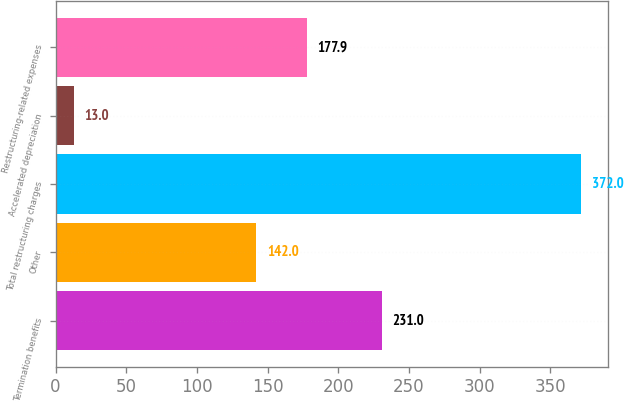Convert chart. <chart><loc_0><loc_0><loc_500><loc_500><bar_chart><fcel>Termination benefits<fcel>Other<fcel>Total restructuring charges<fcel>Accelerated depreciation<fcel>Restructuring-related expenses<nl><fcel>231<fcel>142<fcel>372<fcel>13<fcel>177.9<nl></chart> 